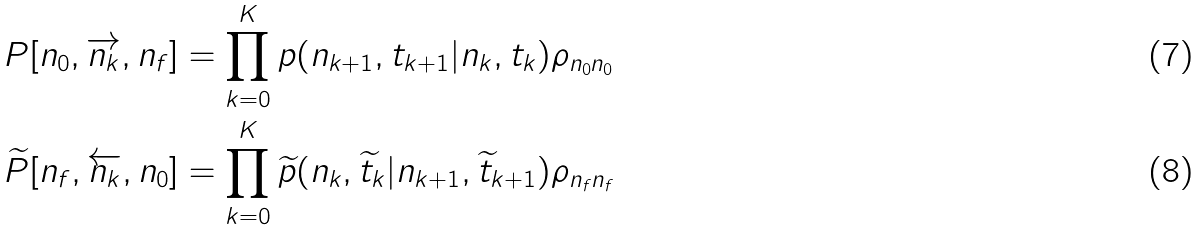<formula> <loc_0><loc_0><loc_500><loc_500>P [ n _ { 0 } , \overrightarrow { n _ { k } } , n _ { f } ] & = \prod _ { k = 0 } ^ { K } p ( n _ { k + 1 } , t _ { k + 1 } | n _ { k } , t _ { k } ) \rho _ { n _ { 0 } n _ { 0 } } \\ \widetilde { P } [ n _ { f } , \overleftarrow { n _ { k } } , n _ { 0 } ] & = \prod _ { k = 0 } ^ { K } \widetilde { p } ( n _ { k } , \widetilde { t } _ { k } | n _ { k + 1 } , \widetilde { t } _ { k + 1 } ) \rho _ { n _ { f } n _ { f } }</formula> 